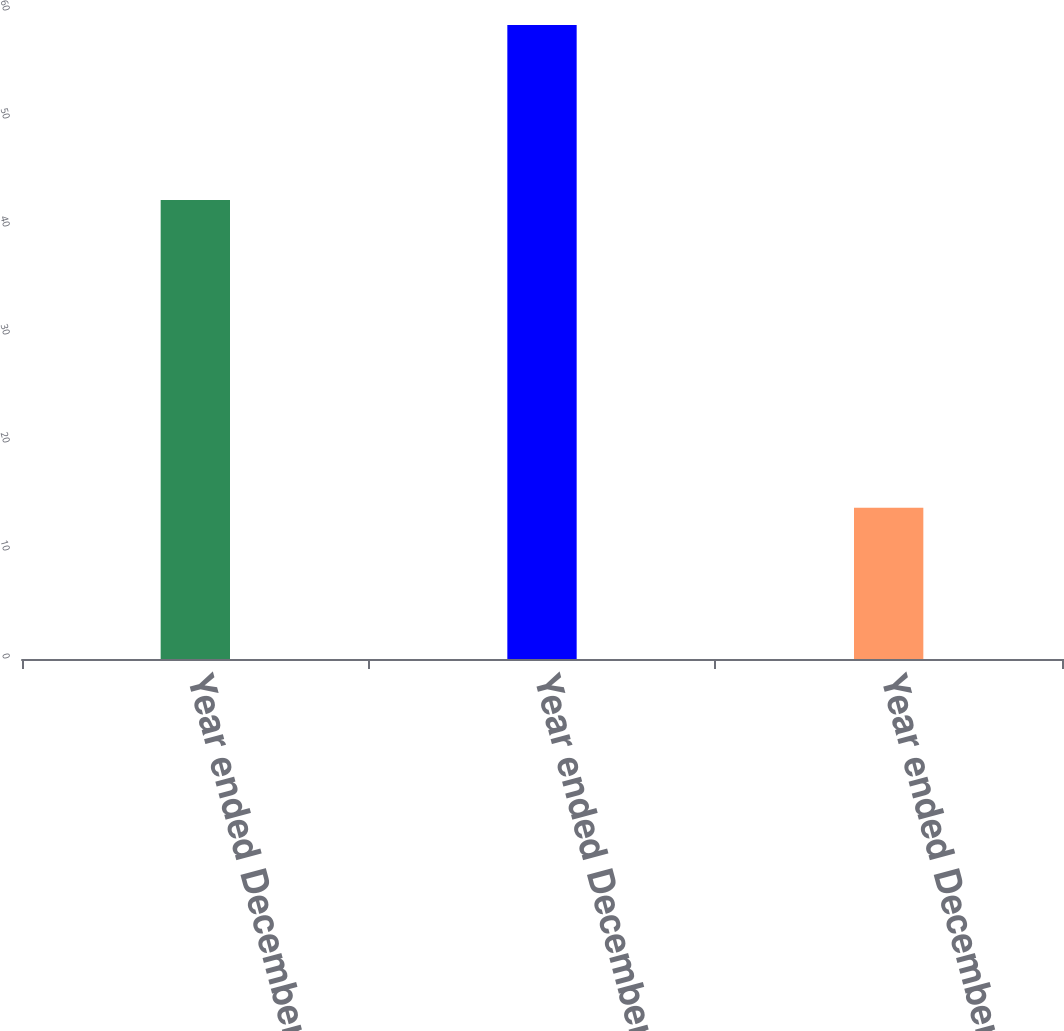<chart> <loc_0><loc_0><loc_500><loc_500><bar_chart><fcel>Year ended December 31 2015<fcel>Year ended December 31 2014<fcel>Year ended December 31 2013<nl><fcel>42.5<fcel>58.7<fcel>14<nl></chart> 